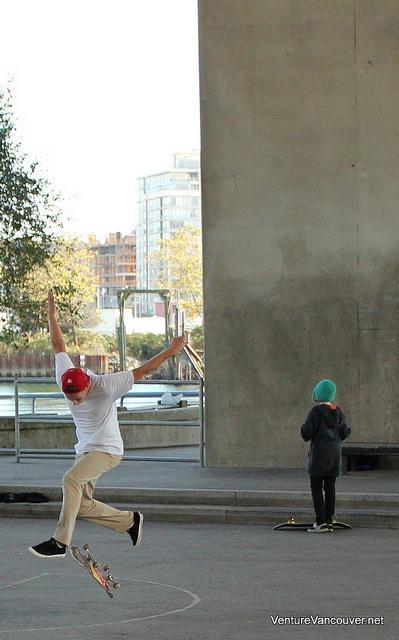How many people are there?
Give a very brief answer. 2. 